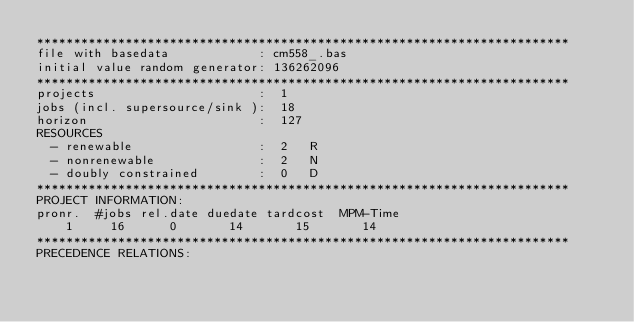Convert code to text. <code><loc_0><loc_0><loc_500><loc_500><_ObjectiveC_>************************************************************************
file with basedata            : cm558_.bas
initial value random generator: 136262096
************************************************************************
projects                      :  1
jobs (incl. supersource/sink ):  18
horizon                       :  127
RESOURCES
  - renewable                 :  2   R
  - nonrenewable              :  2   N
  - doubly constrained        :  0   D
************************************************************************
PROJECT INFORMATION:
pronr.  #jobs rel.date duedate tardcost  MPM-Time
    1     16      0       14       15       14
************************************************************************
PRECEDENCE RELATIONS:</code> 